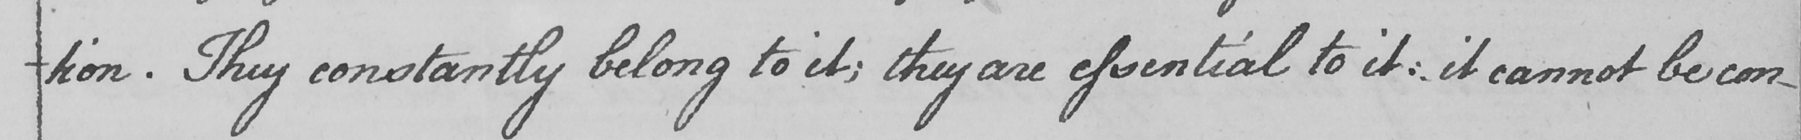What is written in this line of handwriting? -tion . They constantly belong to it ; they are essential to it :  it cannot be con- 